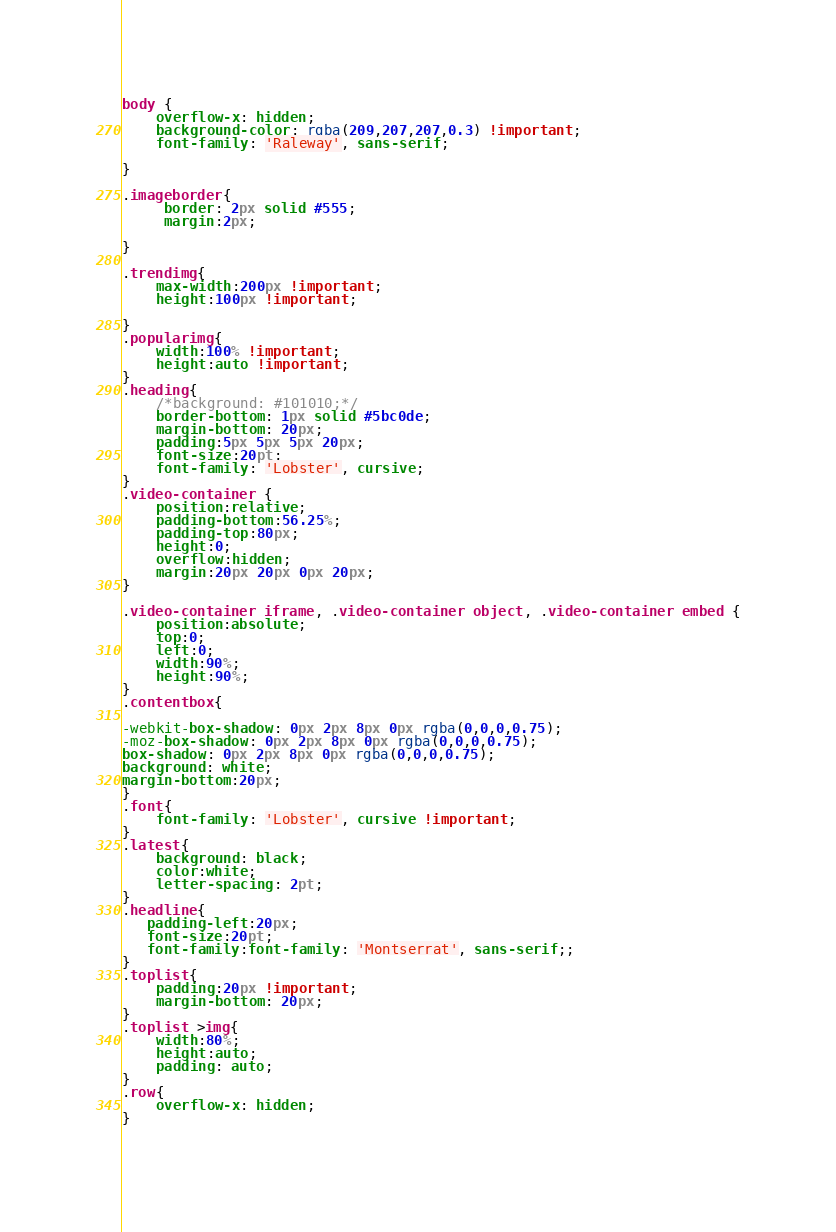Convert code to text. <code><loc_0><loc_0><loc_500><loc_500><_CSS_>body {
	overflow-x: hidden;
	background-color: rgba(209,207,207,0.3) !important;
	font-family: 'Raleway', sans-serif;
	
}

.imageborder{
	 border: 2px solid #555;
	 margin:2px;
   
}

.trendimg{
	max-width:200px !important;
	height:100px !important;

}
.popularimg{
    width:100% !important;
	height:auto !important;
}
.heading{
	/*background: #101010;*/
	border-bottom: 1px solid #5bc0de;
	margin-bottom: 20px;
	padding:5px 5px 5px 20px;
	font-size:20pt;
	font-family: 'Lobster', cursive;
}
.video-container {
	position:relative;
	padding-bottom:56.25%;
	padding-top:80px;
	height:0;
	overflow:hidden;
	margin:20px 20px 0px 20px;
}

.video-container iframe, .video-container object, .video-container embed {
	position:absolute;
	top:0;
	left:0;
	width:90%;
	height:90%;
}
.contentbox{

-webkit-box-shadow: 0px 2px 8px 0px rgba(0,0,0,0.75);
-moz-box-shadow: 0px 2px 8px 0px rgba(0,0,0,0.75);
box-shadow: 0px 2px 8px 0px rgba(0,0,0,0.75);
background: white;
margin-bottom:20px;
}
.font{
	font-family: 'Lobster', cursive !important;
}
.latest{
	background: black;
	color:white;
	letter-spacing: 2pt;
}
.headline{
   padding-left:20px;
   font-size:20pt;
   font-family:font-family: 'Montserrat', sans-serif;;  
}
.toplist{
	padding:20px !important;
	margin-bottom: 20px;
}
.toplist >img{
	width:80%;
	height:auto;
	padding: auto;
}
.row{
	overflow-x: hidden;
}
 </code> 